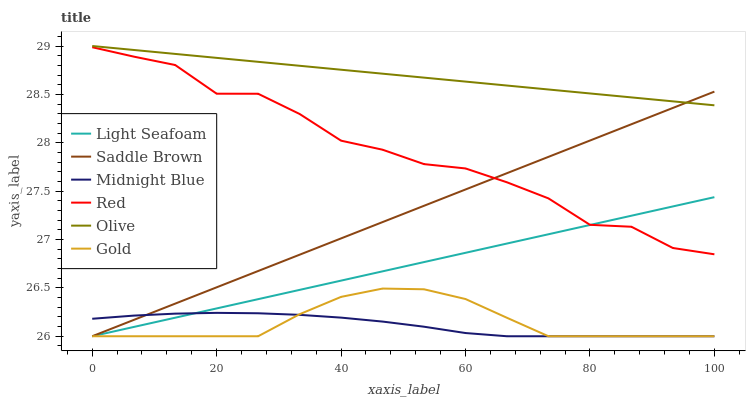Does Midnight Blue have the minimum area under the curve?
Answer yes or no. Yes. Does Olive have the maximum area under the curve?
Answer yes or no. Yes. Does Gold have the minimum area under the curve?
Answer yes or no. No. Does Gold have the maximum area under the curve?
Answer yes or no. No. Is Light Seafoam the smoothest?
Answer yes or no. Yes. Is Red the roughest?
Answer yes or no. Yes. Is Gold the smoothest?
Answer yes or no. No. Is Gold the roughest?
Answer yes or no. No. Does Midnight Blue have the lowest value?
Answer yes or no. Yes. Does Olive have the lowest value?
Answer yes or no. No. Does Olive have the highest value?
Answer yes or no. Yes. Does Gold have the highest value?
Answer yes or no. No. Is Gold less than Olive?
Answer yes or no. Yes. Is Olive greater than Light Seafoam?
Answer yes or no. Yes. Does Saddle Brown intersect Gold?
Answer yes or no. Yes. Is Saddle Brown less than Gold?
Answer yes or no. No. Is Saddle Brown greater than Gold?
Answer yes or no. No. Does Gold intersect Olive?
Answer yes or no. No. 